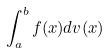Convert formula to latex. <formula><loc_0><loc_0><loc_500><loc_500>\int _ { a } ^ { b } f ( x ) d v ( x )</formula> 